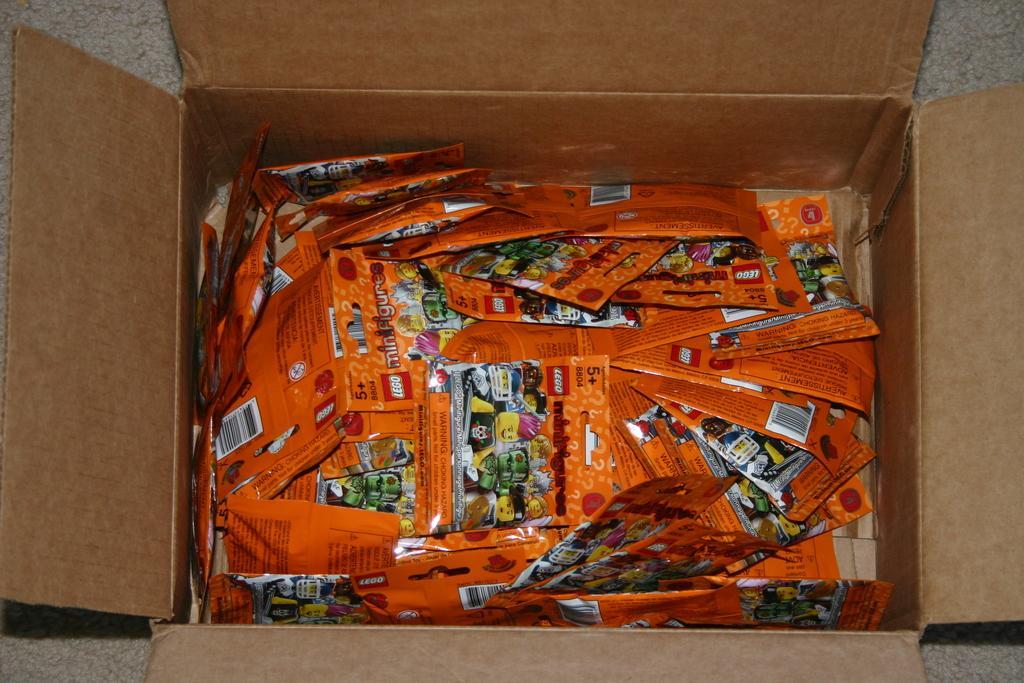How would you summarize this image in a sentence or two? In this image, we can see so many packets in the carton box. Here there is a surface. 